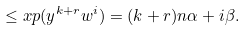Convert formula to latex. <formula><loc_0><loc_0><loc_500><loc_500>\leq x p ( y ^ { k + r } w ^ { i } ) = ( k + r ) n \alpha + i \beta .</formula> 